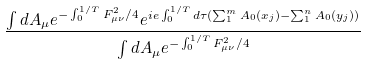<formula> <loc_0><loc_0><loc_500><loc_500>\frac { \int d A _ { \mu } e ^ { - \int _ { 0 } ^ { 1 / T } F _ { \mu \nu } ^ { 2 } / 4 } e ^ { i e \int _ { 0 } ^ { 1 / T } d \tau ( \sum _ { 1 } ^ { m } A _ { 0 } ( x _ { j } ) - \sum _ { 1 } ^ { n } A _ { 0 } ( y _ { j } ) ) } } { \int d A _ { \mu } e ^ { - \int _ { 0 } ^ { 1 / T } F _ { \mu \nu } ^ { 2 } / 4 } }</formula> 